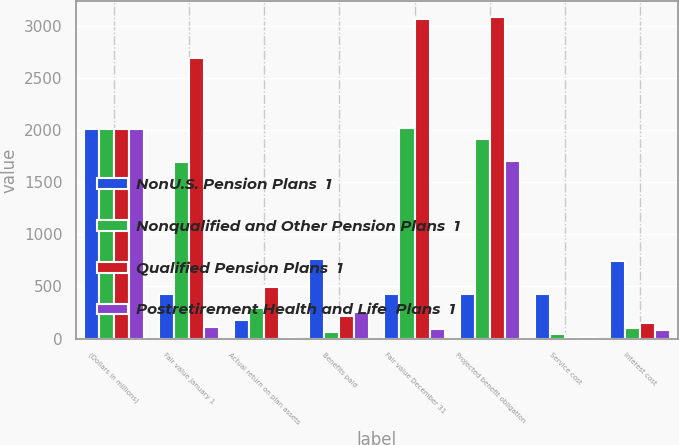<chart> <loc_0><loc_0><loc_500><loc_500><stacked_bar_chart><ecel><fcel>(Dollars in millions)<fcel>Fair value January 1<fcel>Actual return on plan assets<fcel>Benefits paid<fcel>Fair value December 31<fcel>Projected benefit obligation<fcel>Service cost<fcel>Interest cost<nl><fcel>NonU.S. Pension Plans  1<fcel>2011<fcel>423<fcel>182<fcel>760<fcel>423<fcel>423<fcel>423<fcel>746<nl><fcel>Nonqualified and Other Pension Plans  1<fcel>2011<fcel>1691<fcel>295<fcel>63<fcel>2022<fcel>1916<fcel>43<fcel>99<nl><fcel>Qualified Pension Plans  1<fcel>2011<fcel>2689<fcel>493<fcel>220<fcel>3061<fcel>3078<fcel>3<fcel>152<nl><fcel>Postretirement Health and Life  Plans  1<fcel>2011<fcel>108<fcel>2<fcel>255<fcel>91<fcel>1704<fcel>15<fcel>80<nl></chart> 